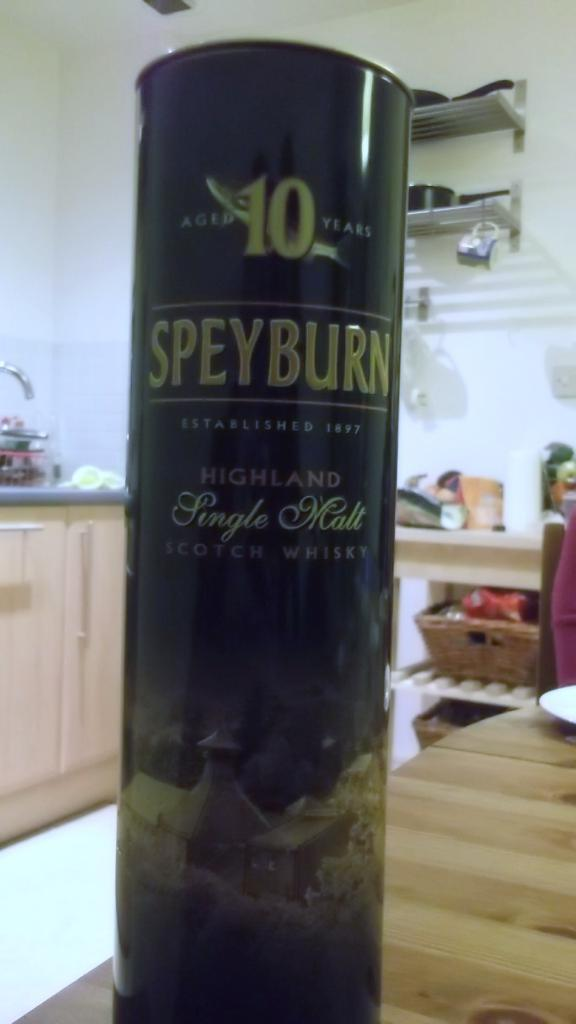<image>
Write a terse but informative summary of the picture. A cylindrical container of Speyburn branded single malt alcohol. 